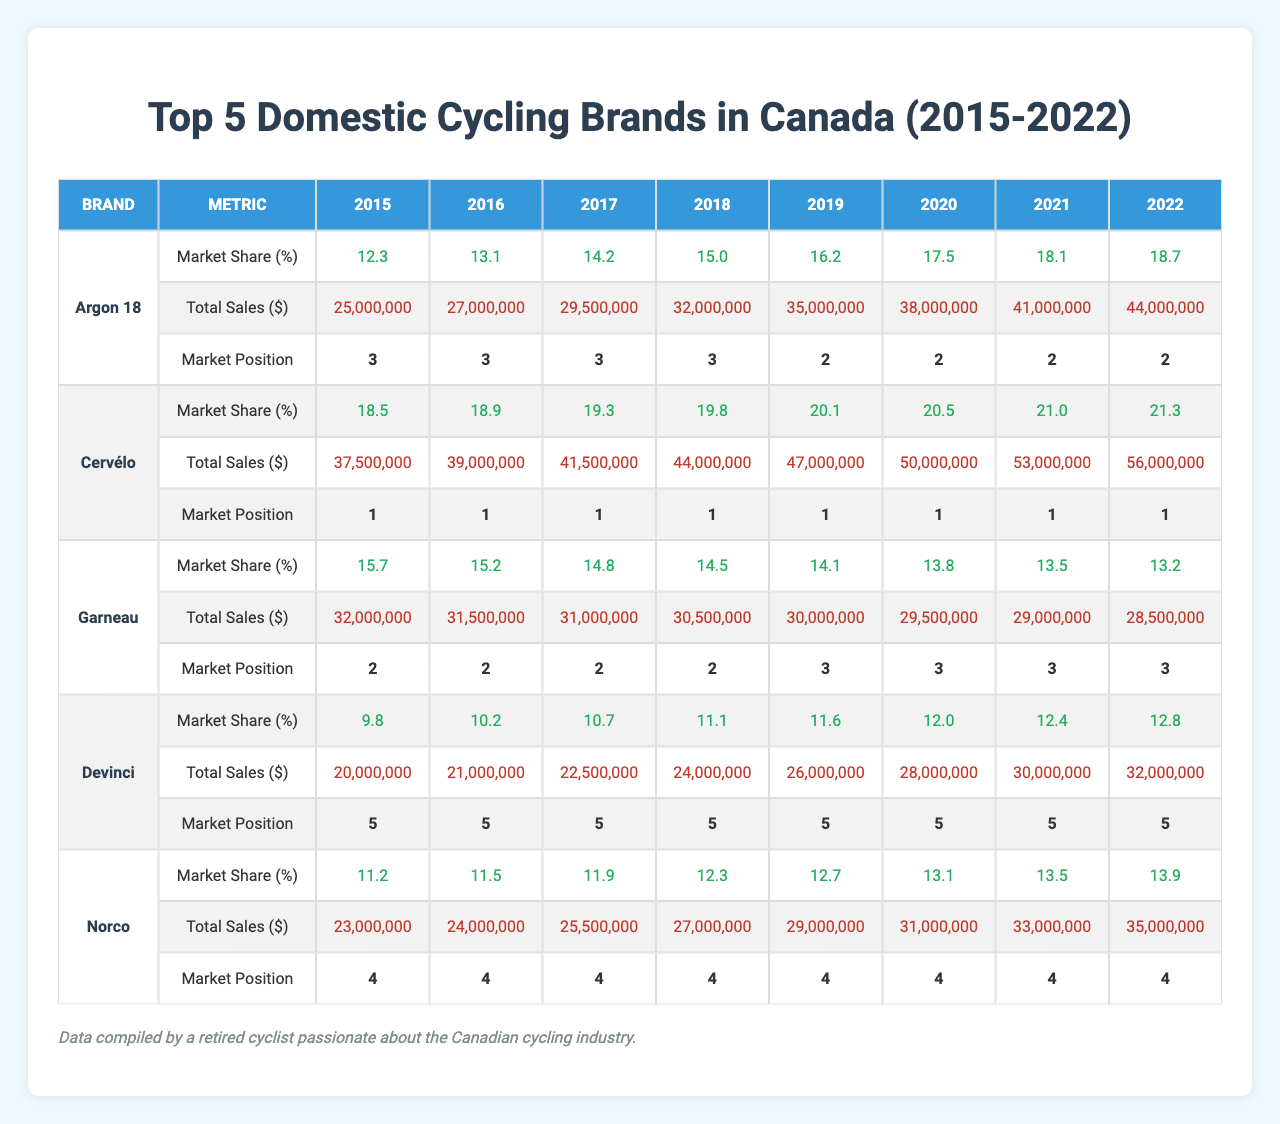What was the market share of Cervélo in 2020? According to the data for Cervélo, the market share in 2020 was 20.5%.
Answer: 20.5% Which brand had the highest market share in 2019? In 2019, Cervélo had the highest market share of 20.1%.
Answer: Cervélo Did Garneau's market share increase or decrease from 2015 to 2022? Garneau's market share decreased from 15.7% in 2015 to 13.2% in 2022.
Answer: Decrease What was the average market share of Argon 18 from 2015 to 2022? The average market share of Argon 18 is calculated as (12.3 + 13.1 + 14.2 + 15.0 + 16.2 + 17.5 + 18.1 + 18.7) / 8 = 15.2%.
Answer: 15.2% Which brand consistently maintained the highest market position between 2015 and 2022? Cervélo consistently maintained the highest market position with a position of 1 each year from 2015 to 2022.
Answer: Cervélo What was the total sales amount for Norco in 2020? For Norco in 2020, the total sales were $31,000,000.
Answer: $31,000,000 Identify the brand with the lowest market share in 2021 and its percentage. In 2021, Garneau had the lowest market share of 13.5%.
Answer: Garneau, 13.5% If you combined total sales for Argon 18 and Devinci in 2018, what would be the total? For Argon 18 in 2018, total sales were $32,000,000; for Devinci it was $24,000,000. The combined total is $32,000,000 + $24,000,000 = $56,000,000.
Answer: $56,000,000 What was the market share difference between Cervélo and Norco in 2017? In 2017, Cervélo had a market share of 19.3%, while Norco had 11.9%. The difference is 19.3% - 11.9% = 7.4%.
Answer: 7.4% In which year did Devinci reach its highest market share and what was that percentage? Devinci reached its highest market share in 2022 with a percentage of 12.8%.
Answer: 12.8% in 2022 